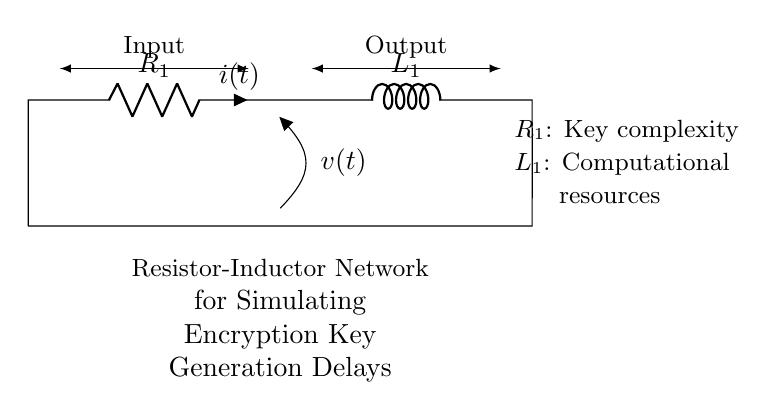What components are present in this circuit? The components in the circuit are a resistor and an inductor, which are labeled as R1 and L1 respectively.
Answer: Resistor and Inductor What does R1 represent in the context of this circuit? R1 represents key complexity, indicating that it has a role in influencing how difficult the encryption key generation becomes based on its resistance value.
Answer: Key complexity What is the current flow direction in this circuit? The current flow direction is from the input through R1, into L1, and then back to the ground. It is indicated by the label 'i(t)' in the diagram, which describes how the current varies with time.
Answer: From input to output What type of circuit is this? This is a resistor-inductor circuit designed to simulate encryption key generation delays by creating delays in current responses through the inductor.
Answer: Resistor-Inductor What is the significance of the voltage indicated as v(t)? The voltage v(t) in the circuit likely represents the voltage across the resistor, which provides insights into how the key generation process reacts to input changes over time.
Answer: Voltage across the resistor How do R1 and L1 interact in this circuit? R1 and L1 create a dynamic circuit where the resistor limits the current flow, while the inductor adds an element of reactance, resulting in delays in the build-up and drop of current, essential for simulating secure encryption processes.
Answer: They create delays 